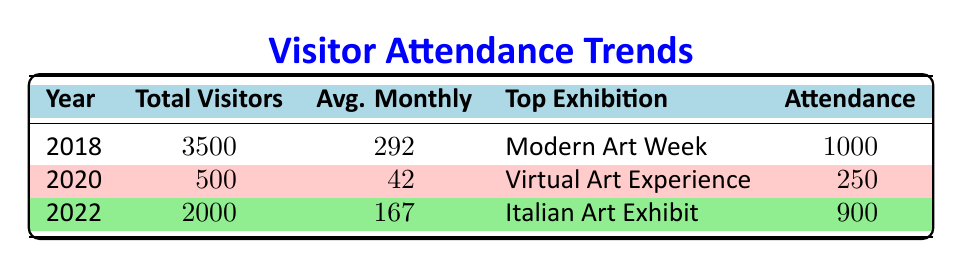What was the total number of visitors in 2018? The table specifies the total visitors for each year. In 2018, the total number of visitors is listed as 3500.
Answer: 3500 What is the average monthly visitor count for the year 2022? The table shows the average monthly visitors for 2022. This value is explicitly given as 167.
Answer: 167 Which exhibition had the highest attendance in 2018? The table lists the top exhibitions for each year along with their attendance. In 2018, the exhibition with the highest attendance was 'Modern Art Week' with 1000 visitors.
Answer: Modern Art Week How many total visitors were there across all years listed in the table? Total visitors from each year are 3500 (2018) + 500 (2020) + 2000 (2022) = 6000.
Answer: 6000 Did the attendance at any exhibition in 2020 exceed the attendance of 250 visitors? The table shows the attendance for the exhibitions in 2020, both being 250 visitors. Therefore, the attendance did not exceed 250 visitors.
Answer: No What was the percentage decrease in total visitors from 2018 to 2020? The total visitors in 2018 were 3500, and in 2020 they were 500. The decrease is 3500 - 500 = 3000. The percentage decrease is (3000 / 3500) * 100 = 85.71%.
Answer: 85.71% How many more total visitors were there in 2022 compared to 2020? The total visitors in 2022 are 2000 and in 2020 are 500. The difference is 2000 - 500 = 1500.
Answer: 1500 Was the average monthly attendance higher in 2022 than in 2018? The average monthly attendance in 2022 is 167, and in 2018 it is 292. Since 167 is less than 292, the average was not higher in 2022.
Answer: No What proportion of visitors in 2022 attended the 'Emerging Artists' exhibition? The total visitors in 2022 are 2000 and the attendance for 'Emerging Artists' is 600. To find the proportion, divide 600 by 2000, which is 0.3 or 30%.
Answer: 30% Which year had the lowest average monthly visitors? The average monthly visitors listed are 292 for 2018, 42 for 2020, and 167 for 2022. 2020 has the lowest at 42.
Answer: 2020 